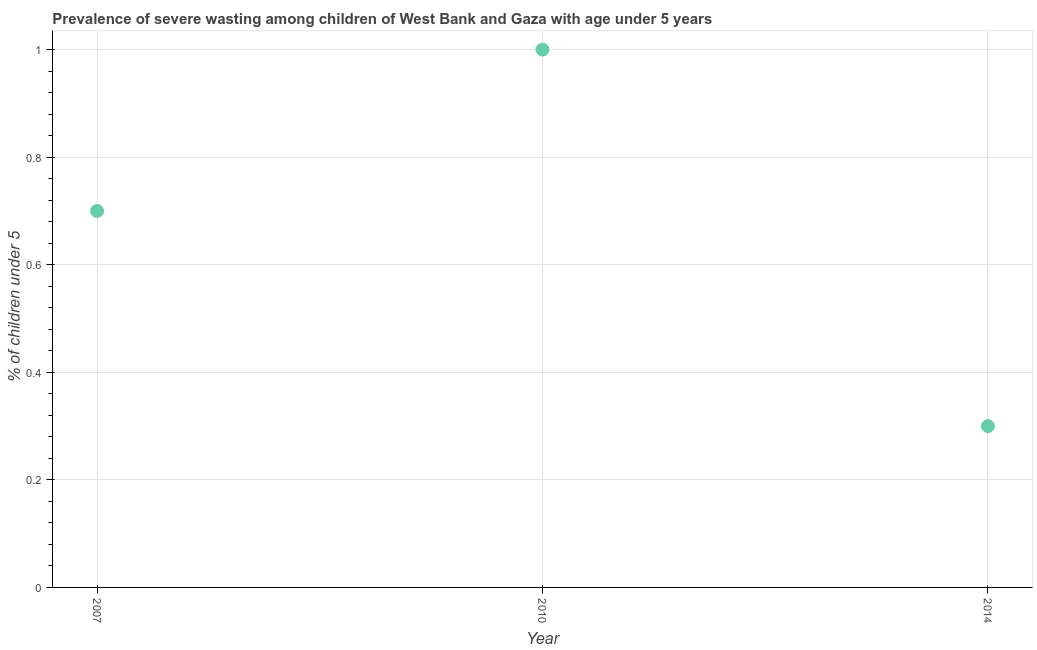Across all years, what is the maximum prevalence of severe wasting?
Your answer should be compact. 1. Across all years, what is the minimum prevalence of severe wasting?
Keep it short and to the point. 0.3. In which year was the prevalence of severe wasting maximum?
Provide a succinct answer. 2010. In which year was the prevalence of severe wasting minimum?
Provide a short and direct response. 2014. What is the difference between the prevalence of severe wasting in 2010 and 2014?
Keep it short and to the point. 0.7. What is the average prevalence of severe wasting per year?
Your answer should be very brief. 0.67. What is the median prevalence of severe wasting?
Your response must be concise. 0.7. Do a majority of the years between 2007 and 2010 (inclusive) have prevalence of severe wasting greater than 0.4 %?
Your response must be concise. Yes. What is the ratio of the prevalence of severe wasting in 2007 to that in 2010?
Provide a succinct answer. 0.7. What is the difference between the highest and the second highest prevalence of severe wasting?
Ensure brevity in your answer.  0.3. Is the sum of the prevalence of severe wasting in 2007 and 2010 greater than the maximum prevalence of severe wasting across all years?
Offer a terse response. Yes. What is the difference between the highest and the lowest prevalence of severe wasting?
Provide a succinct answer. 0.7. In how many years, is the prevalence of severe wasting greater than the average prevalence of severe wasting taken over all years?
Your answer should be compact. 2. How many dotlines are there?
Your response must be concise. 1. How many years are there in the graph?
Offer a very short reply. 3. What is the difference between two consecutive major ticks on the Y-axis?
Give a very brief answer. 0.2. Does the graph contain any zero values?
Give a very brief answer. No. Does the graph contain grids?
Your answer should be very brief. Yes. What is the title of the graph?
Provide a short and direct response. Prevalence of severe wasting among children of West Bank and Gaza with age under 5 years. What is the label or title of the Y-axis?
Your answer should be compact.  % of children under 5. What is the  % of children under 5 in 2007?
Offer a terse response. 0.7. What is the  % of children under 5 in 2010?
Offer a very short reply. 1. What is the  % of children under 5 in 2014?
Keep it short and to the point. 0.3. What is the difference between the  % of children under 5 in 2007 and 2010?
Provide a succinct answer. -0.3. What is the difference between the  % of children under 5 in 2007 and 2014?
Keep it short and to the point. 0.4. What is the difference between the  % of children under 5 in 2010 and 2014?
Ensure brevity in your answer.  0.7. What is the ratio of the  % of children under 5 in 2007 to that in 2010?
Provide a short and direct response. 0.7. What is the ratio of the  % of children under 5 in 2007 to that in 2014?
Give a very brief answer. 2.33. What is the ratio of the  % of children under 5 in 2010 to that in 2014?
Ensure brevity in your answer.  3.33. 